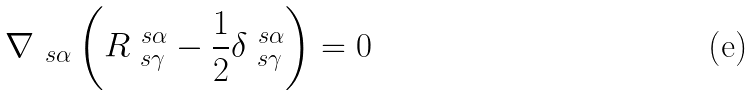Convert formula to latex. <formula><loc_0><loc_0><loc_500><loc_500>\nabla _ { \ s \alpha } \left ( R ^ { \ s \alpha } _ { \ s \gamma } - \frac { 1 } { 2 } \delta ^ { \ s \alpha } _ { \ s \gamma } \right ) = 0</formula> 